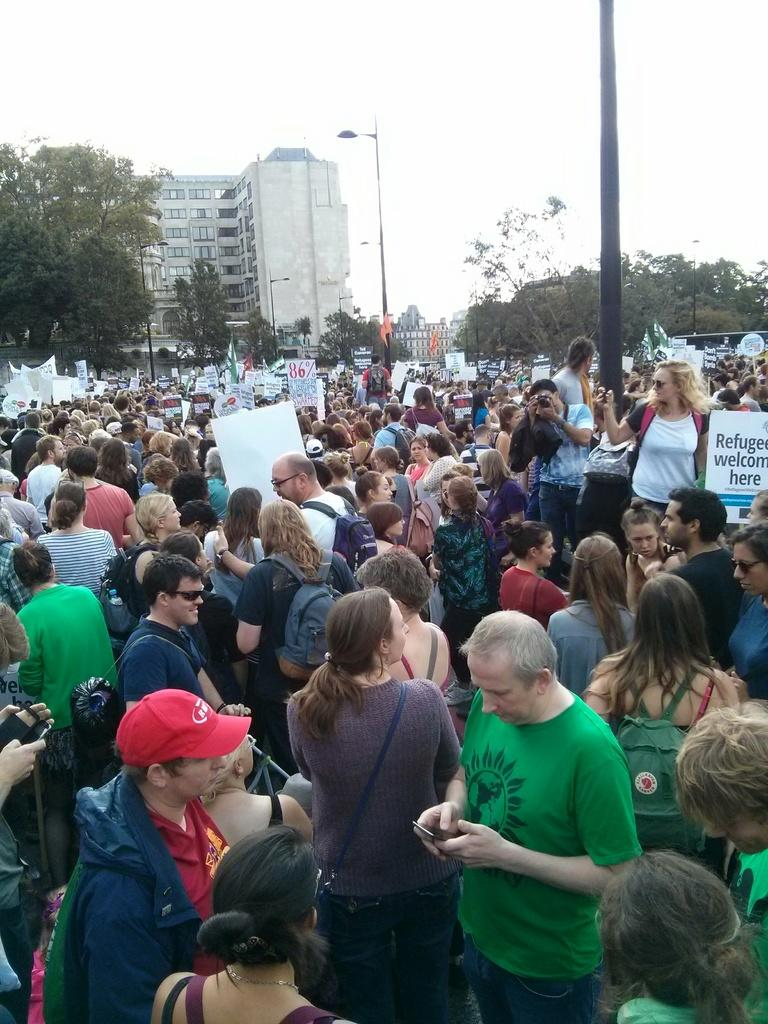What can be seen in the image? There are people standing in the image. What is visible in the background of the image? There are trees, buildings, the sky, and poles in the background of the image. What type of bomb is being diffused in the image? There is no bomb present in the image; it features people standing with various background elements. 